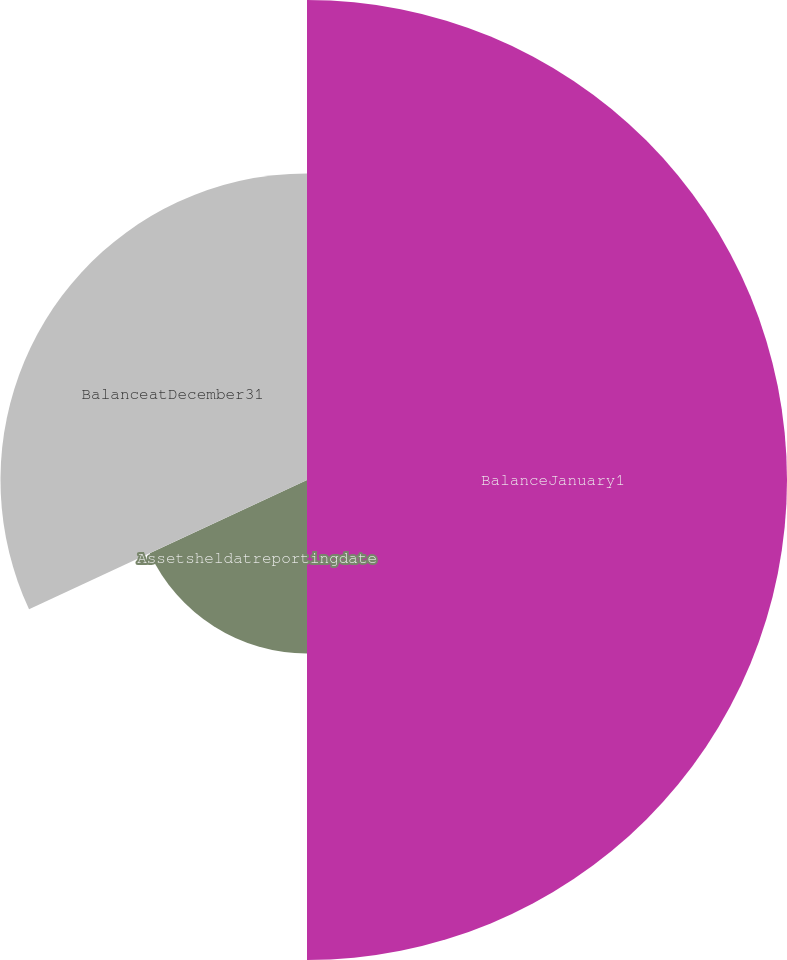<chart> <loc_0><loc_0><loc_500><loc_500><pie_chart><fcel>BalanceJanuary1<fcel>Assetsheldatreportingdate<fcel>BalanceatDecember31<nl><fcel>50.0%<fcel>18.07%<fcel>31.93%<nl></chart> 